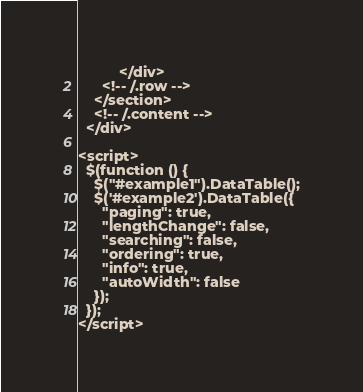<code> <loc_0><loc_0><loc_500><loc_500><_PHP_>          </div>
      <!-- /.row -->
    </section>
    <!-- /.content -->
  </div>

<script>
  $(function () {
    $("#example1").DataTable();
    $('#example2').DataTable({
      "paging": true,
      "lengthChange": false,
      "searching": false,
      "ordering": true,
      "info": true,
      "autoWidth": false
    });
  });
</script></code> 